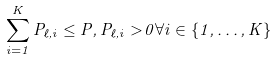Convert formula to latex. <formula><loc_0><loc_0><loc_500><loc_500>\sum _ { i = 1 } ^ { K } P _ { \ell , i } \leq P , P _ { \ell , i } > 0 \forall i \in \{ 1 , \dots , K \}</formula> 